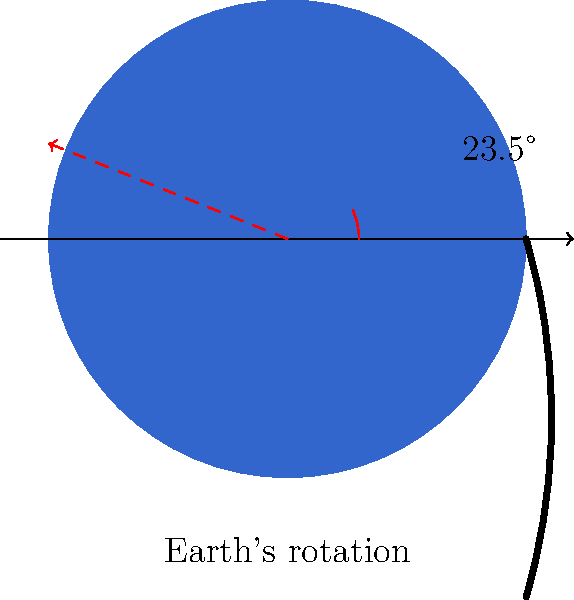Alright, hoops fans! Let's pivot from the court to the cosmos. If Earth is spinning like Giannis' basketball on his finger, how long does it take for our cosmic slam dunk to make one full rotation? Bonus points: Why don't we feel like we're on a basketball-themed merry-go-round? Let's break down this cosmic play:

1. Earth's rotation period:
   - Just like a basketball spins on a player's finger, Earth rotates on its axis.
   - This rotation takes approximately 24 hours, which we call a day.
   - To be precise, it's 23 hours, 56 minutes, and 4 seconds for one complete rotation relative to the stars (sidereal day).

2. Why we don't feel the spin:
   a) Constant speed: Earth's rotation is smooth and consistent, like a well-executed spin move.
   b) Gravity: It keeps us firmly planted on the surface, just like a player's grip on the ball.
   c) Atmosphere: It rotates with us, eliminating any feeling of wind resistance.
   d) Slow angular velocity: Despite Earth's size, the spin is relatively slow (about 1,000 mph at the equator), making it imperceptible to us.

3. Effects we can observe:
   - The Coriolis effect: Influences weather patterns and ocean currents, like a curve ball in space.
   - Day and night cycle: As Earth rotates, different parts face the Sun, creating our game clock of day and night.

4. The tilt factor:
   - Earth's axis is tilted at 23.5° (as shown in the diagram), which leads to seasons.
   - This tilt is like a player's signature move, giving Earth its unique characteristics.

In basketball terms, Earth's rotation is like a perfect spin on the finger - smooth, consistent, and crucial to the game of life on our planet.
Answer: 24 hours (23 hours, 56 minutes, 4 seconds for sidereal day) 